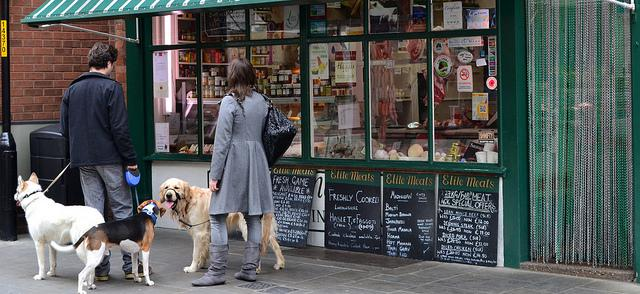What type of animals are shown?

Choices:
A) stuffed
B) aquatic
C) wild
D) domestic domestic 